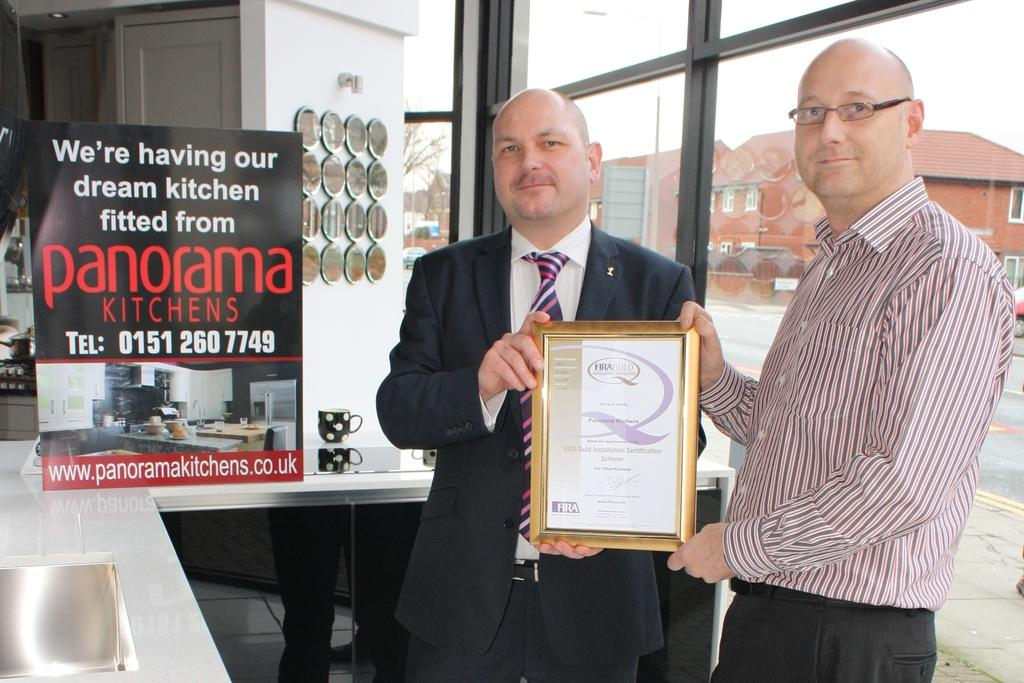<image>
Describe the image concisely. Two men stand holding an award between them and next to them is a sign that says panorama on it. 